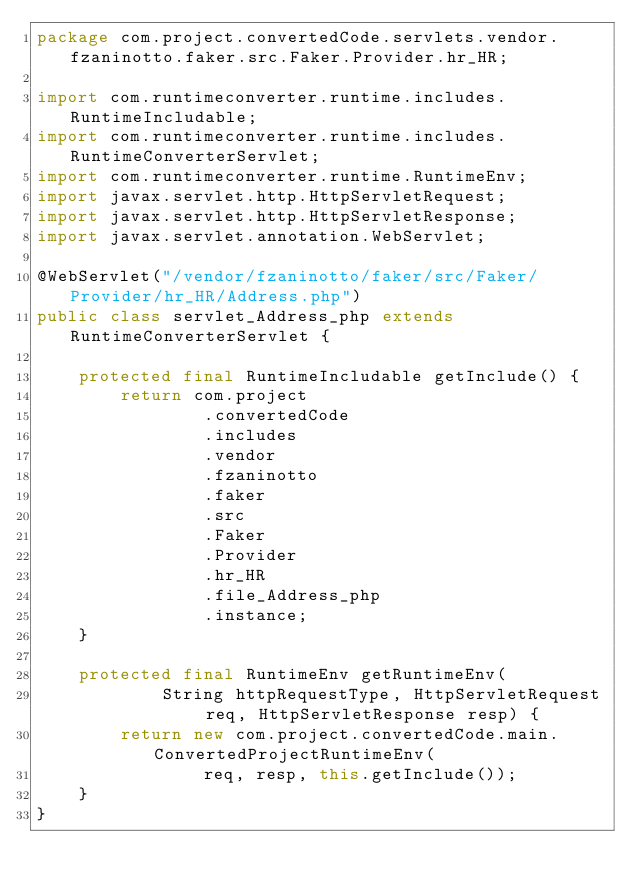<code> <loc_0><loc_0><loc_500><loc_500><_Java_>package com.project.convertedCode.servlets.vendor.fzaninotto.faker.src.Faker.Provider.hr_HR;

import com.runtimeconverter.runtime.includes.RuntimeIncludable;
import com.runtimeconverter.runtime.includes.RuntimeConverterServlet;
import com.runtimeconverter.runtime.RuntimeEnv;
import javax.servlet.http.HttpServletRequest;
import javax.servlet.http.HttpServletResponse;
import javax.servlet.annotation.WebServlet;

@WebServlet("/vendor/fzaninotto/faker/src/Faker/Provider/hr_HR/Address.php")
public class servlet_Address_php extends RuntimeConverterServlet {

    protected final RuntimeIncludable getInclude() {
        return com.project
                .convertedCode
                .includes
                .vendor
                .fzaninotto
                .faker
                .src
                .Faker
                .Provider
                .hr_HR
                .file_Address_php
                .instance;
    }

    protected final RuntimeEnv getRuntimeEnv(
            String httpRequestType, HttpServletRequest req, HttpServletResponse resp) {
        return new com.project.convertedCode.main.ConvertedProjectRuntimeEnv(
                req, resp, this.getInclude());
    }
}
</code> 